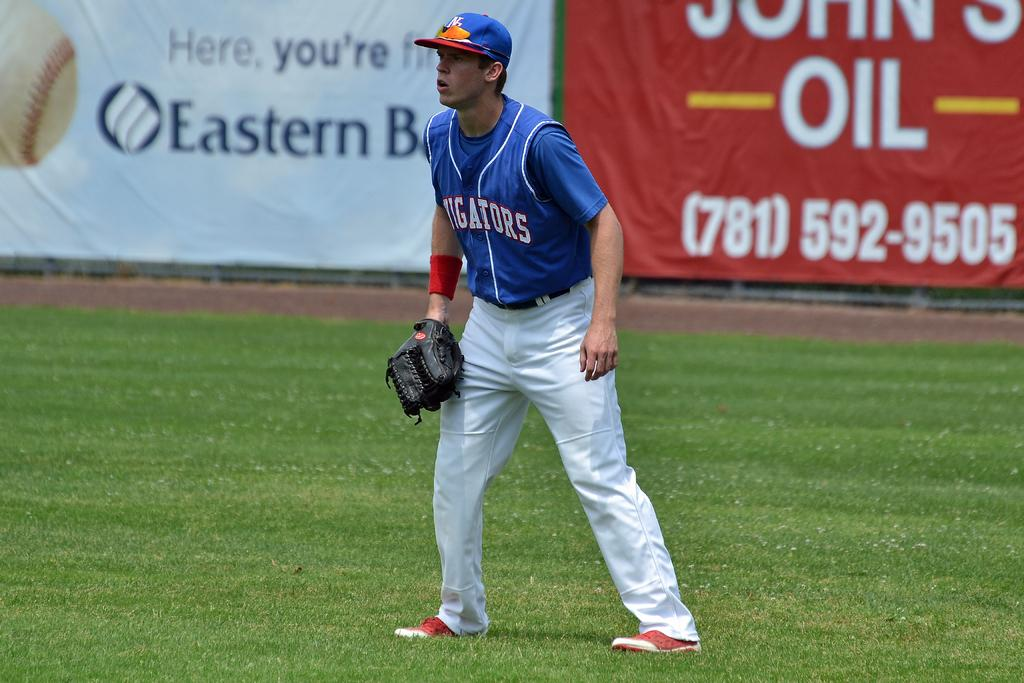Provide a one-sentence caption for the provided image. A baseball game with a banner advertising the phone number (781)592-9505 behind a player. 